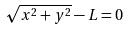Convert formula to latex. <formula><loc_0><loc_0><loc_500><loc_500>\sqrt { x ^ { 2 } + y ^ { 2 } } - L = 0</formula> 